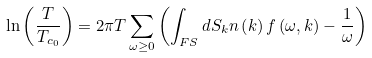Convert formula to latex. <formula><loc_0><loc_0><loc_500><loc_500>\ln \left ( \frac { T } { T _ { c _ { 0 } } } \right ) = 2 \pi T \sum _ { \omega \geq 0 } \left ( \int _ { F S } d S _ { k } n \left ( { k } \right ) f \left ( \omega , { k } \right ) - \frac { 1 } { \omega } \right )</formula> 